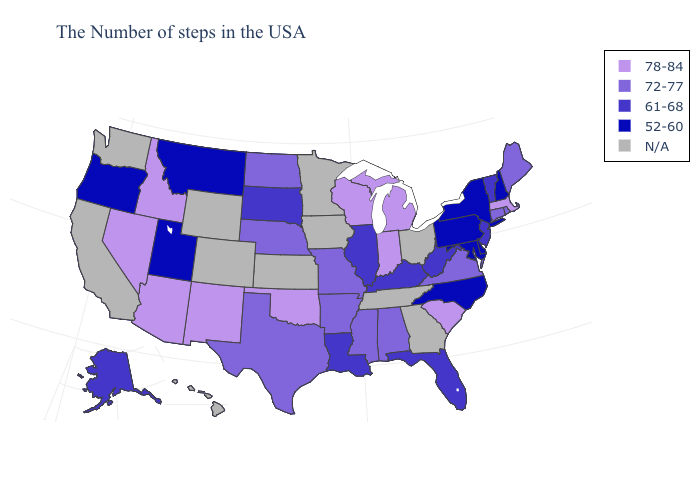What is the value of Idaho?
Quick response, please. 78-84. Among the states that border West Virginia , which have the highest value?
Keep it brief. Virginia. Name the states that have a value in the range 78-84?
Quick response, please. Massachusetts, South Carolina, Michigan, Indiana, Wisconsin, Oklahoma, New Mexico, Arizona, Idaho, Nevada. What is the lowest value in the USA?
Quick response, please. 52-60. What is the lowest value in states that border New York?
Quick response, please. 52-60. Name the states that have a value in the range 78-84?
Concise answer only. Massachusetts, South Carolina, Michigan, Indiana, Wisconsin, Oklahoma, New Mexico, Arizona, Idaho, Nevada. What is the value of Tennessee?
Quick response, please. N/A. What is the highest value in states that border Georgia?
Quick response, please. 78-84. Which states hav the highest value in the West?
Write a very short answer. New Mexico, Arizona, Idaho, Nevada. What is the highest value in states that border North Dakota?
Quick response, please. 61-68. Among the states that border Missouri , which have the highest value?
Answer briefly. Oklahoma. Name the states that have a value in the range N/A?
Give a very brief answer. Ohio, Georgia, Tennessee, Minnesota, Iowa, Kansas, Wyoming, Colorado, California, Washington, Hawaii. Name the states that have a value in the range 61-68?
Answer briefly. Vermont, New Jersey, West Virginia, Florida, Kentucky, Illinois, Louisiana, South Dakota, Alaska. What is the value of New Mexico?
Concise answer only. 78-84. What is the lowest value in the Northeast?
Quick response, please. 52-60. 